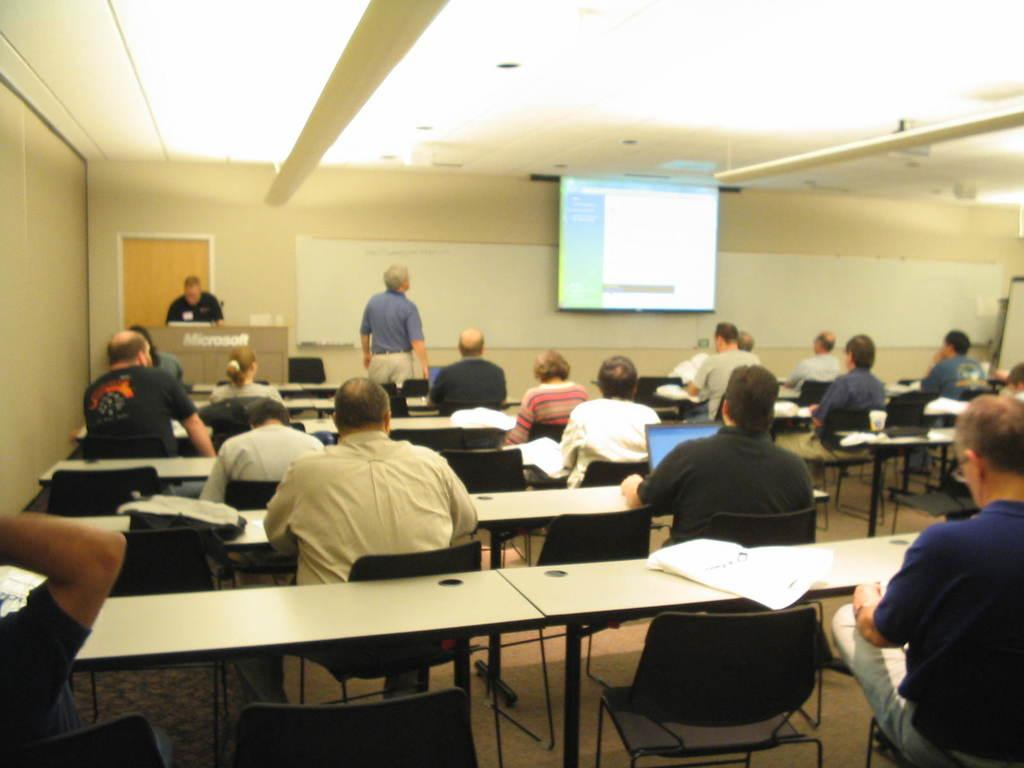What type of furniture is present in the image? There is a table in the image. Are there any chairs associated with the table? Yes, there are chairs behind the table. What are the people in the chairs doing? The people sitting in the chairs are likely engaged in a meeting or discussion. What can be seen in the background of the image? There is a wall in the background of the image. What is on the wall? There is a screen on the wall. How many children are present in the image, and what decision are they making? There are no children present in the image, and no decision-making process is depicted. 